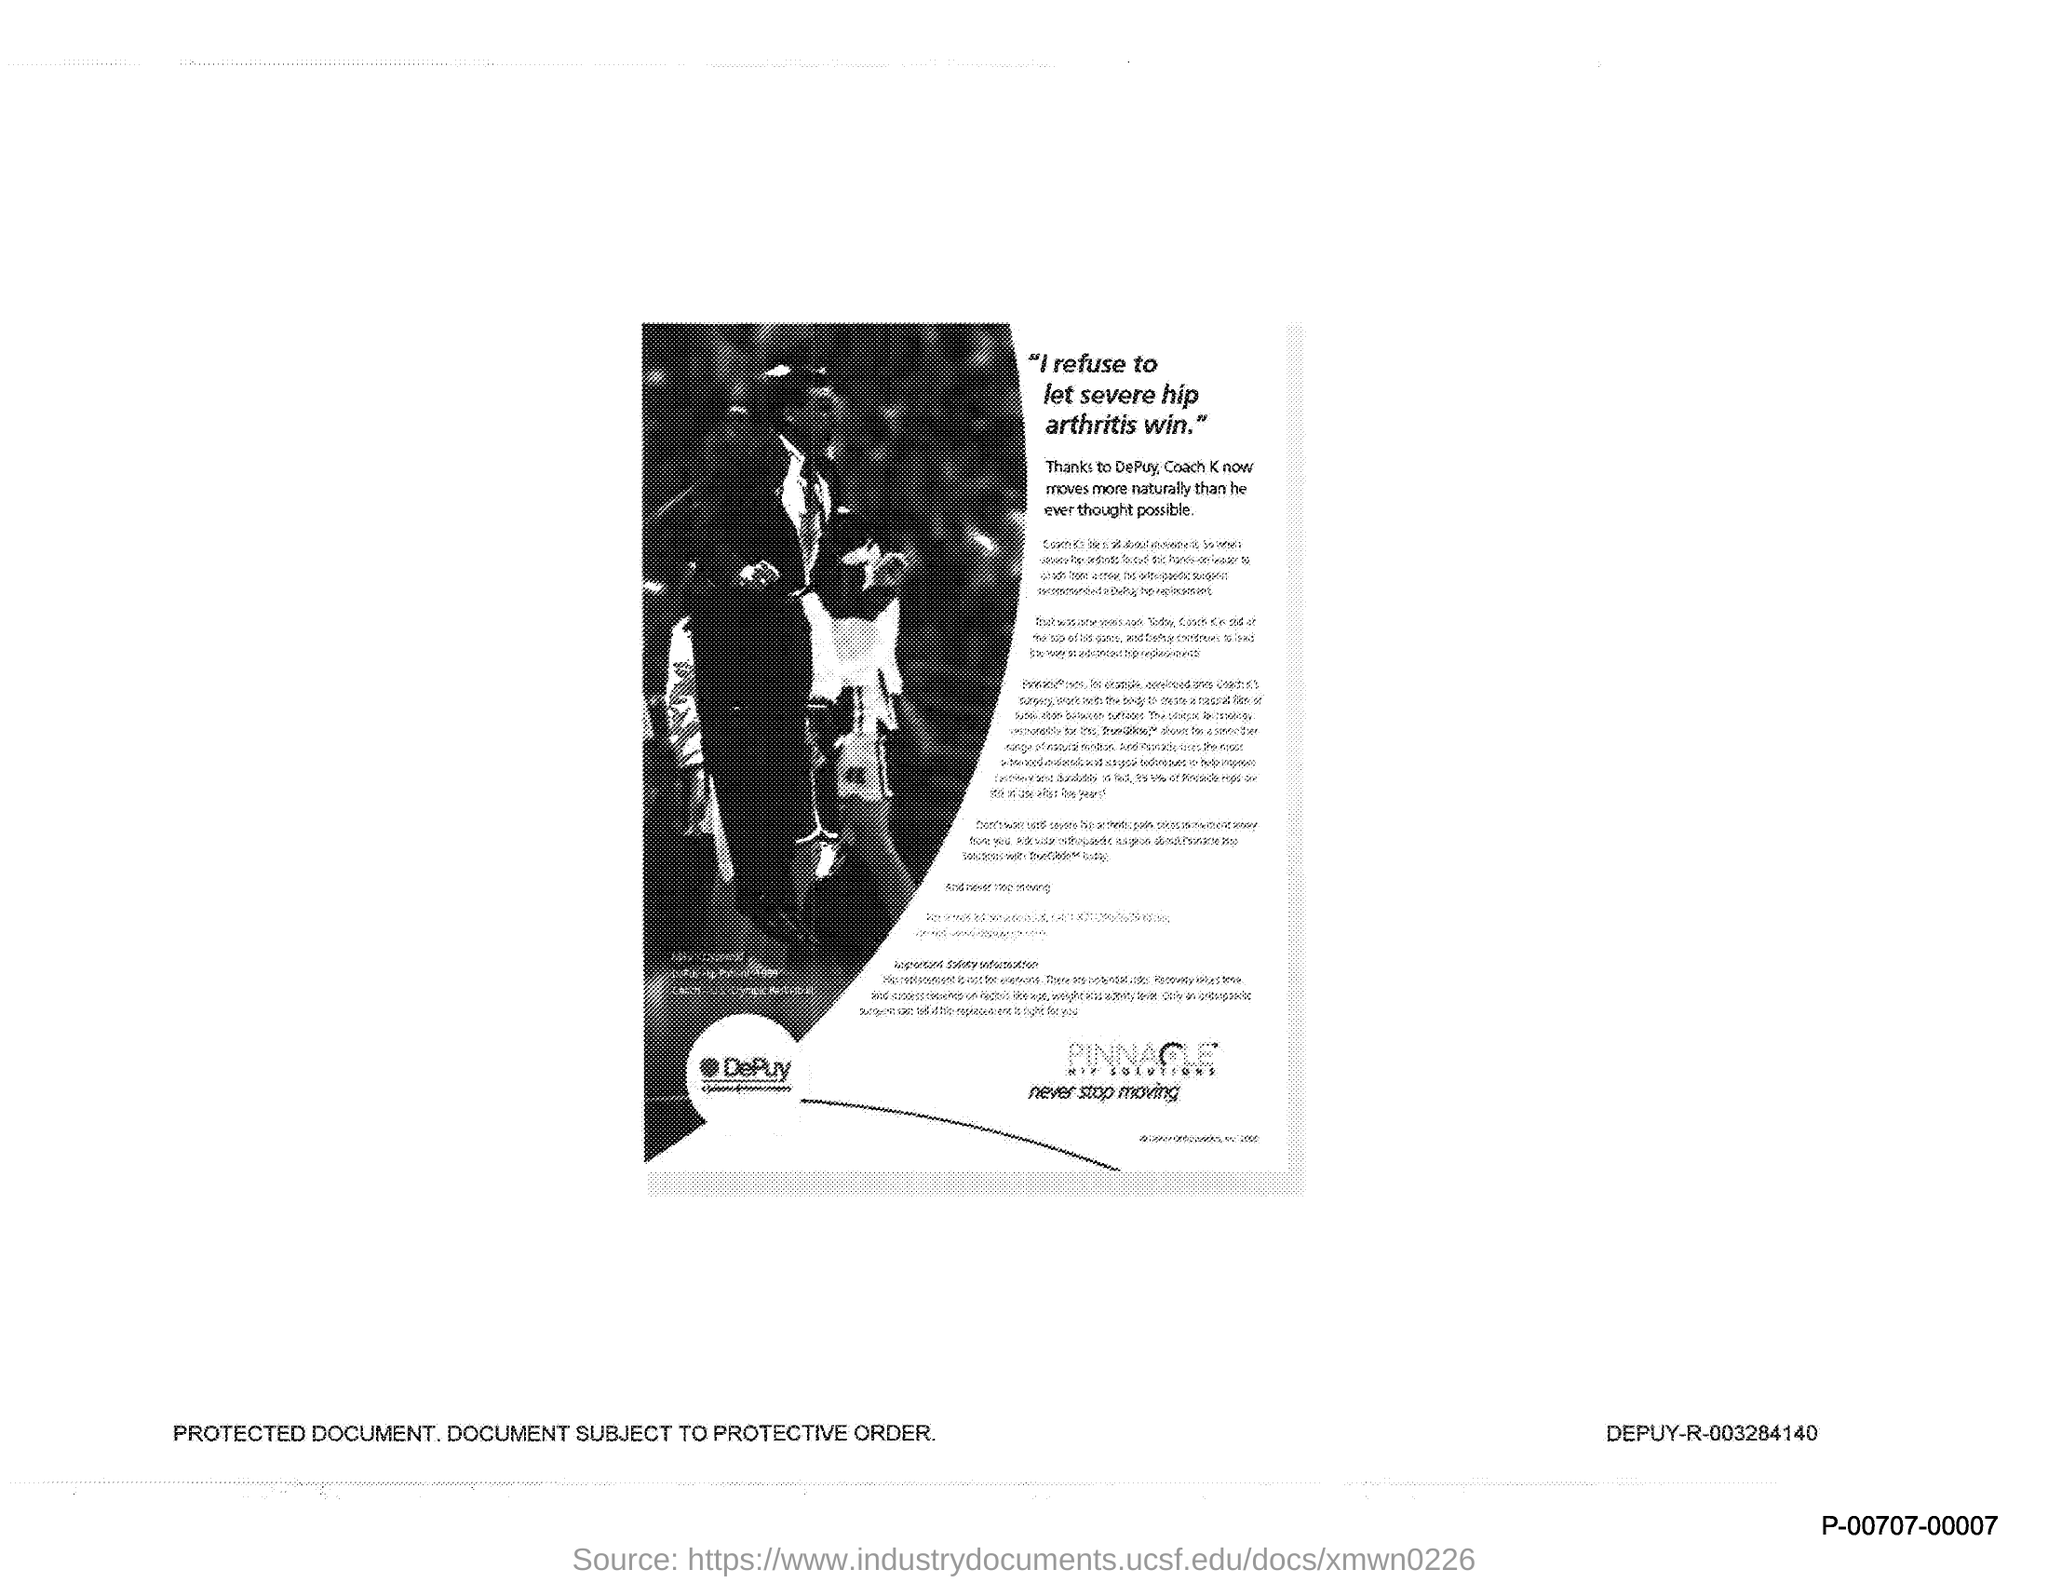Give some essential details in this illustration. The document titled "I refuse to let severe hip arthritis win." declares a refusal to let hip arthritis impede one's ability to live life to the fullest. 